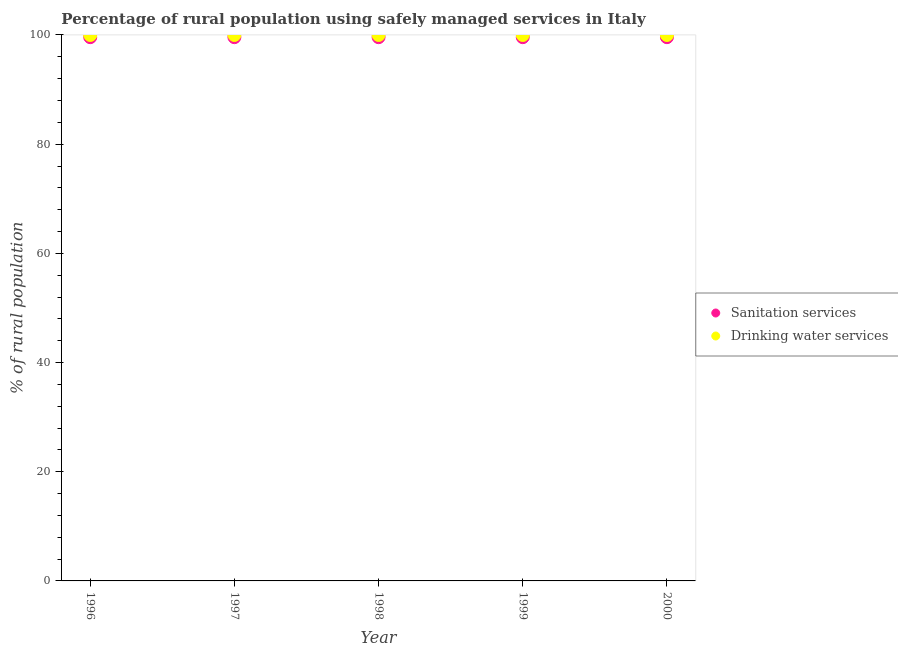What is the percentage of rural population who used drinking water services in 2000?
Your response must be concise. 100. Across all years, what is the maximum percentage of rural population who used sanitation services?
Your answer should be very brief. 99.6. Across all years, what is the minimum percentage of rural population who used drinking water services?
Ensure brevity in your answer.  100. In which year was the percentage of rural population who used sanitation services maximum?
Offer a terse response. 1996. What is the total percentage of rural population who used sanitation services in the graph?
Your response must be concise. 498. What is the difference between the percentage of rural population who used drinking water services in 1998 and the percentage of rural population who used sanitation services in 1996?
Offer a terse response. 0.4. What is the average percentage of rural population who used drinking water services per year?
Make the answer very short. 100. In the year 2000, what is the difference between the percentage of rural population who used drinking water services and percentage of rural population who used sanitation services?
Your response must be concise. 0.4. In how many years, is the percentage of rural population who used sanitation services greater than 44 %?
Provide a succinct answer. 5. What is the ratio of the percentage of rural population who used drinking water services in 1999 to that in 2000?
Your answer should be very brief. 1. Is the difference between the percentage of rural population who used drinking water services in 1996 and 1997 greater than the difference between the percentage of rural population who used sanitation services in 1996 and 1997?
Keep it short and to the point. No. What is the difference between the highest and the second highest percentage of rural population who used drinking water services?
Provide a succinct answer. 0. Is the sum of the percentage of rural population who used drinking water services in 1996 and 2000 greater than the maximum percentage of rural population who used sanitation services across all years?
Make the answer very short. Yes. Does the percentage of rural population who used sanitation services monotonically increase over the years?
Give a very brief answer. No. Is the percentage of rural population who used sanitation services strictly less than the percentage of rural population who used drinking water services over the years?
Offer a terse response. Yes. How many dotlines are there?
Make the answer very short. 2. How many years are there in the graph?
Provide a short and direct response. 5. Does the graph contain any zero values?
Offer a terse response. No. Does the graph contain grids?
Make the answer very short. No. How are the legend labels stacked?
Your answer should be compact. Vertical. What is the title of the graph?
Your answer should be very brief. Percentage of rural population using safely managed services in Italy. What is the label or title of the Y-axis?
Give a very brief answer. % of rural population. What is the % of rural population in Sanitation services in 1996?
Offer a terse response. 99.6. What is the % of rural population of Sanitation services in 1997?
Offer a very short reply. 99.6. What is the % of rural population of Sanitation services in 1998?
Keep it short and to the point. 99.6. What is the % of rural population of Drinking water services in 1998?
Provide a succinct answer. 100. What is the % of rural population in Sanitation services in 1999?
Give a very brief answer. 99.6. What is the % of rural population of Sanitation services in 2000?
Your answer should be compact. 99.6. Across all years, what is the maximum % of rural population of Sanitation services?
Provide a succinct answer. 99.6. Across all years, what is the maximum % of rural population in Drinking water services?
Your response must be concise. 100. Across all years, what is the minimum % of rural population in Sanitation services?
Keep it short and to the point. 99.6. What is the total % of rural population in Sanitation services in the graph?
Your response must be concise. 498. What is the difference between the % of rural population of Sanitation services in 1996 and that in 1998?
Offer a terse response. 0. What is the difference between the % of rural population of Sanitation services in 1996 and that in 1999?
Your answer should be very brief. 0. What is the difference between the % of rural population of Drinking water services in 1996 and that in 1999?
Make the answer very short. 0. What is the difference between the % of rural population in Sanitation services in 1996 and that in 2000?
Offer a very short reply. 0. What is the difference between the % of rural population of Sanitation services in 1997 and that in 1998?
Your response must be concise. 0. What is the difference between the % of rural population of Drinking water services in 1997 and that in 2000?
Provide a short and direct response. 0. What is the difference between the % of rural population of Sanitation services in 1998 and that in 1999?
Your answer should be very brief. 0. What is the difference between the % of rural population of Sanitation services in 1998 and that in 2000?
Keep it short and to the point. 0. What is the difference between the % of rural population in Drinking water services in 1998 and that in 2000?
Provide a short and direct response. 0. What is the difference between the % of rural population in Sanitation services in 1999 and that in 2000?
Offer a very short reply. 0. What is the difference between the % of rural population of Drinking water services in 1999 and that in 2000?
Provide a succinct answer. 0. What is the difference between the % of rural population in Sanitation services in 1996 and the % of rural population in Drinking water services in 1999?
Provide a succinct answer. -0.4. What is the difference between the % of rural population in Sanitation services in 1996 and the % of rural population in Drinking water services in 2000?
Keep it short and to the point. -0.4. What is the difference between the % of rural population of Sanitation services in 1997 and the % of rural population of Drinking water services in 1998?
Offer a very short reply. -0.4. What is the difference between the % of rural population of Sanitation services in 1997 and the % of rural population of Drinking water services in 1999?
Make the answer very short. -0.4. What is the difference between the % of rural population of Sanitation services in 1997 and the % of rural population of Drinking water services in 2000?
Make the answer very short. -0.4. What is the average % of rural population in Sanitation services per year?
Your response must be concise. 99.6. In the year 1997, what is the difference between the % of rural population in Sanitation services and % of rural population in Drinking water services?
Ensure brevity in your answer.  -0.4. In the year 1998, what is the difference between the % of rural population in Sanitation services and % of rural population in Drinking water services?
Provide a succinct answer. -0.4. In the year 1999, what is the difference between the % of rural population of Sanitation services and % of rural population of Drinking water services?
Provide a short and direct response. -0.4. What is the ratio of the % of rural population in Drinking water services in 1996 to that in 1997?
Give a very brief answer. 1. What is the ratio of the % of rural population of Drinking water services in 1996 to that in 1998?
Provide a succinct answer. 1. What is the ratio of the % of rural population of Drinking water services in 1997 to that in 1998?
Offer a terse response. 1. What is the ratio of the % of rural population in Sanitation services in 1997 to that in 1999?
Offer a very short reply. 1. What is the ratio of the % of rural population of Drinking water services in 1997 to that in 1999?
Provide a short and direct response. 1. What is the ratio of the % of rural population of Drinking water services in 1997 to that in 2000?
Offer a terse response. 1. What is the ratio of the % of rural population in Sanitation services in 1998 to that in 1999?
Give a very brief answer. 1. What is the ratio of the % of rural population in Drinking water services in 1998 to that in 1999?
Keep it short and to the point. 1. What is the ratio of the % of rural population in Drinking water services in 1998 to that in 2000?
Keep it short and to the point. 1. What is the difference between the highest and the lowest % of rural population in Drinking water services?
Offer a terse response. 0. 